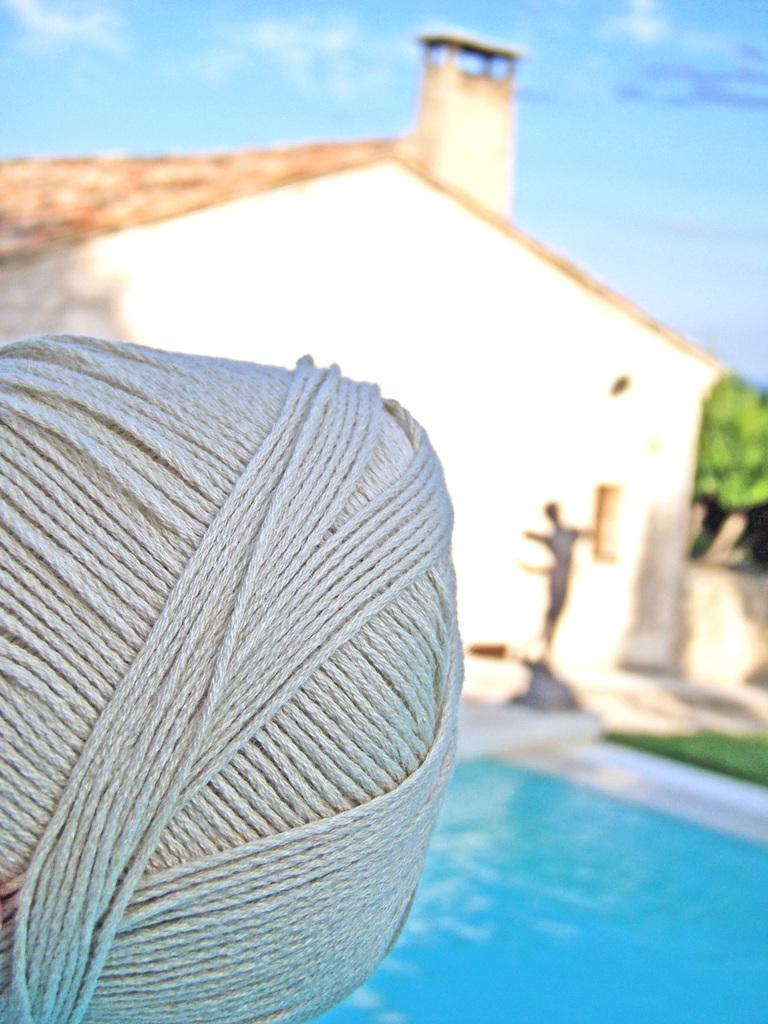What is present in the image that is related to textiles or crafts? There is a yarn in the image. What type of recreational facility can be seen in the image? There is a swimming pool in the image. What type of structure is visible in the image? There is a building in the image. What type of vegetation is present in the image? There are trees in the image. What part of the natural environment is visible in the image? The sky is visible in the image, and it contains clouds. How does the yarn help to pull the dirt out of the swimming pool in the image? The yarn does not help to pull dirt out of the swimming pool in the image; it is not related to cleaning or maintenance. 